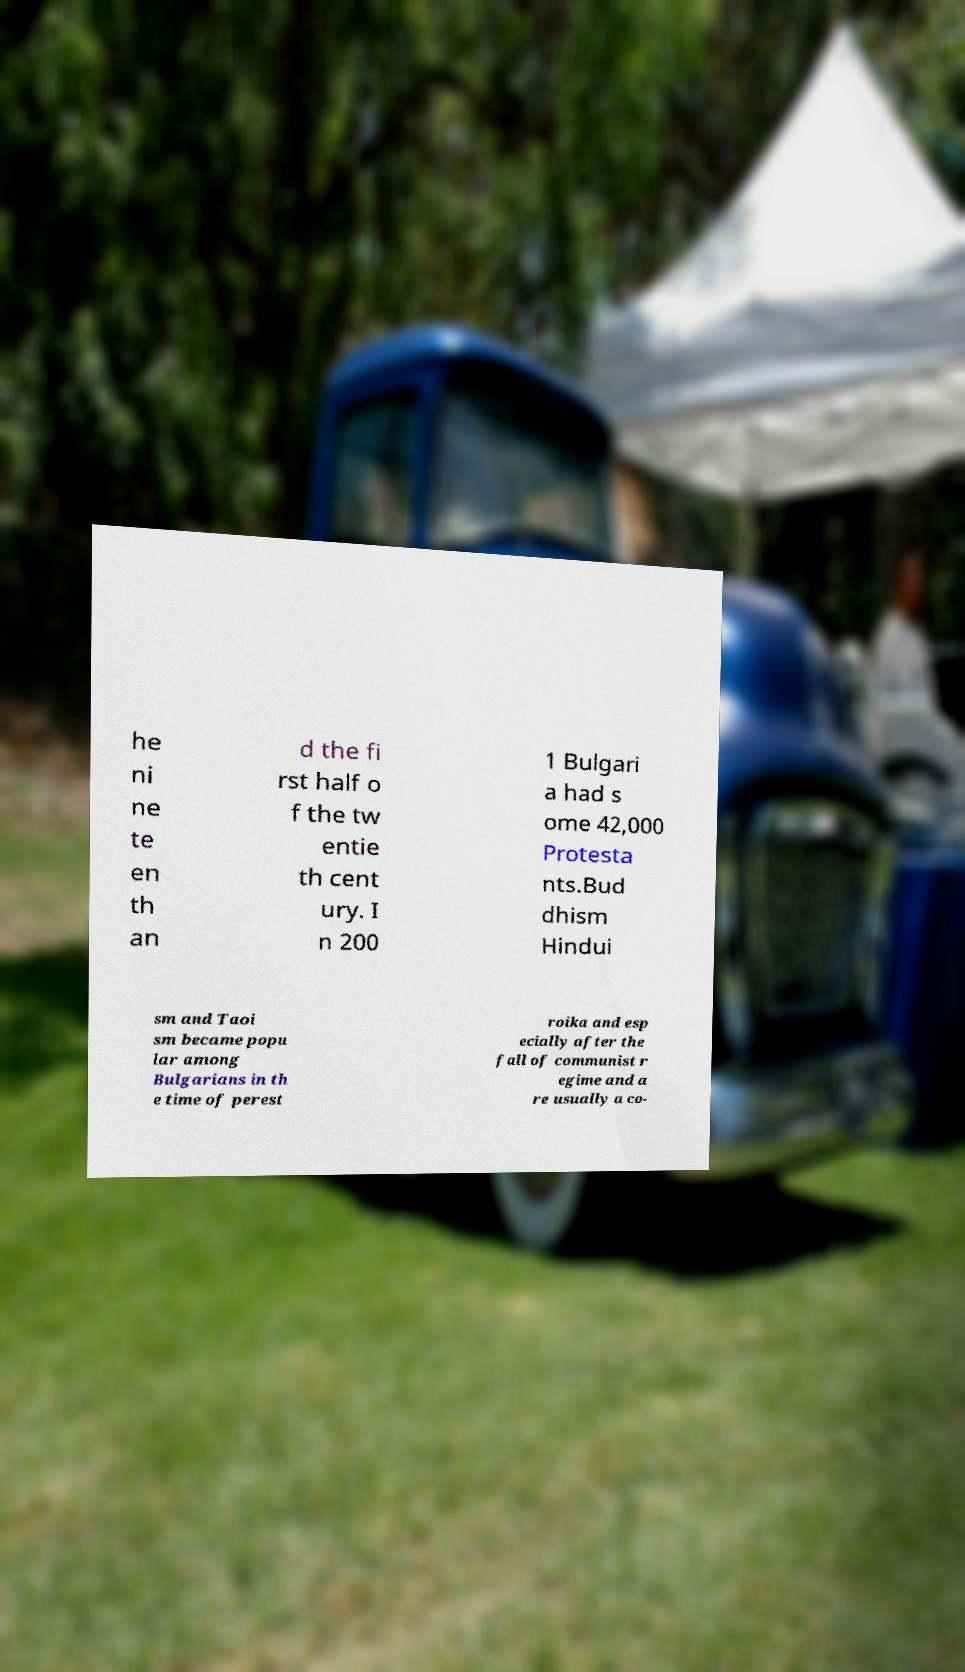Can you read and provide the text displayed in the image?This photo seems to have some interesting text. Can you extract and type it out for me? he ni ne te en th an d the fi rst half o f the tw entie th cent ury. I n 200 1 Bulgari a had s ome 42,000 Protesta nts.Bud dhism Hindui sm and Taoi sm became popu lar among Bulgarians in th e time of perest roika and esp ecially after the fall of communist r egime and a re usually a co- 